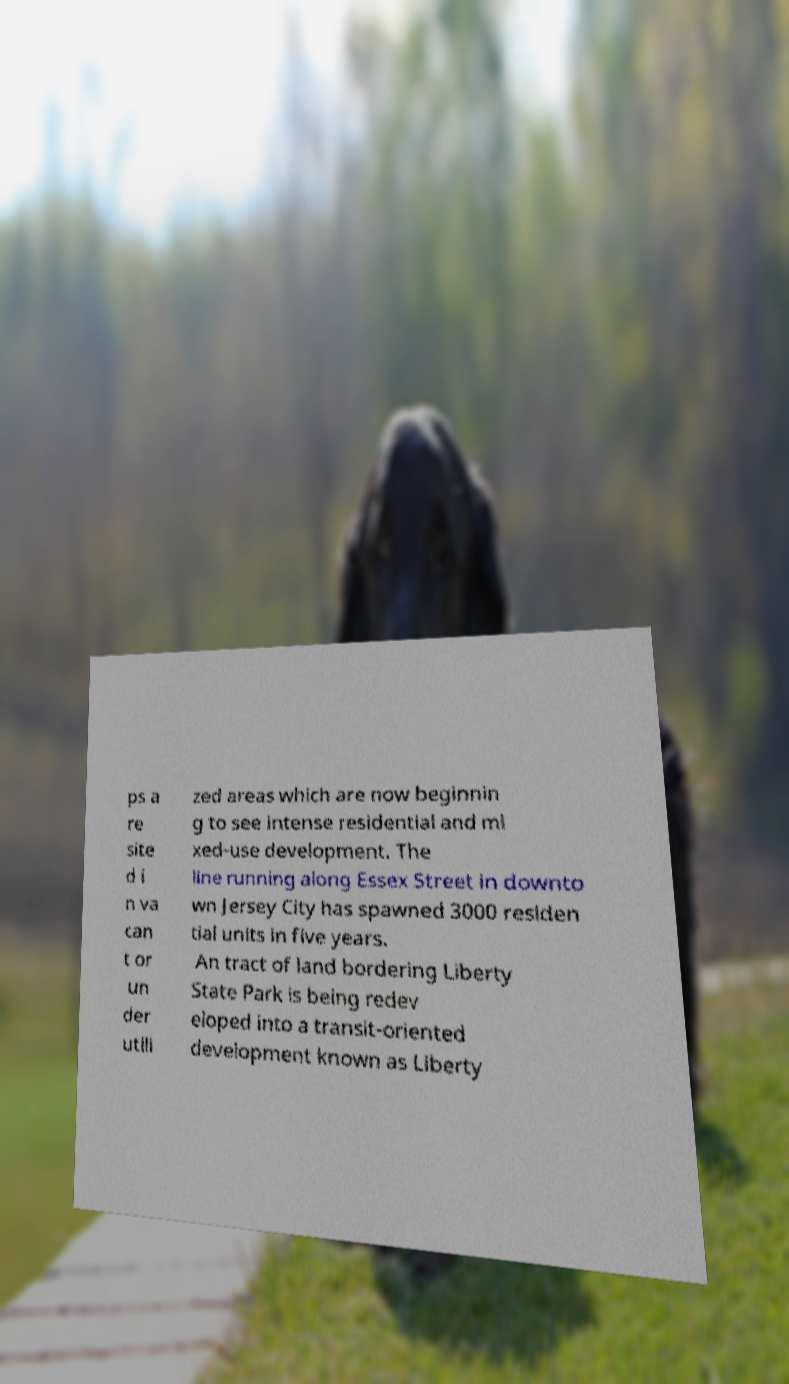I need the written content from this picture converted into text. Can you do that? ps a re site d i n va can t or un der utili zed areas which are now beginnin g to see intense residential and mi xed-use development. The line running along Essex Street in downto wn Jersey City has spawned 3000 residen tial units in five years. An tract of land bordering Liberty State Park is being redev eloped into a transit-oriented development known as Liberty 